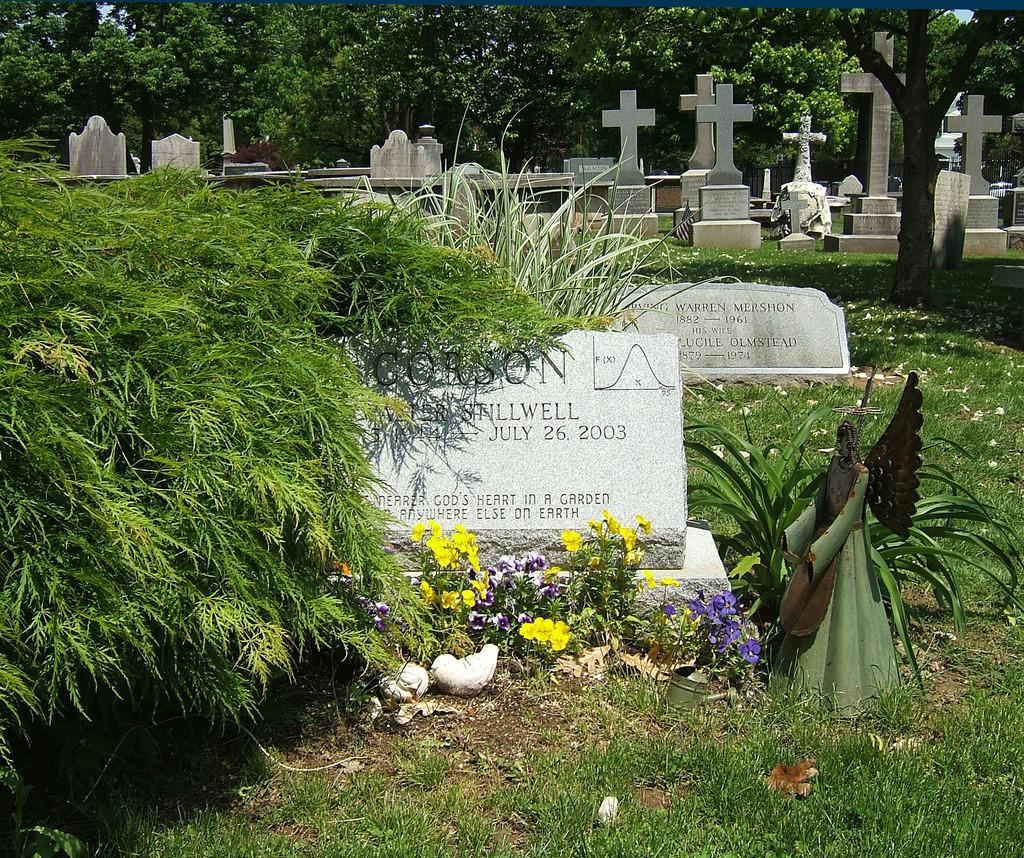What type of location is depicted in the image? The image contains a cemetery. What can be seen on the ground in the cemetery? There are graves on the ground in the image. What is the color of the graves? The graves are white in color. What type of vegetation is present in the image? There are plants in the image. What can be seen in the background of the image? There are trees in the background of the image. What type of meat is being served at the selection in the image? There is no selection or meat present in the image; it depicts a cemetery with graves and vegetation. 